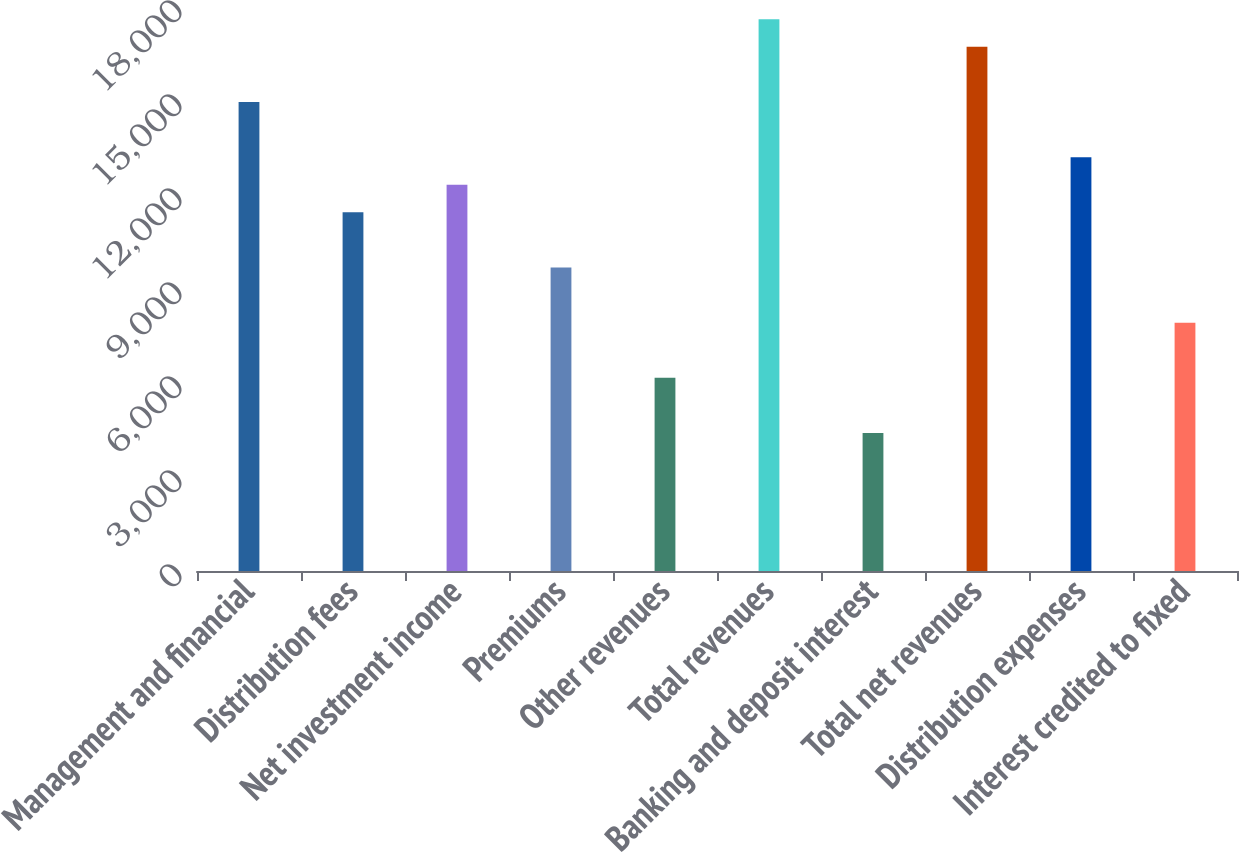Convert chart to OTSL. <chart><loc_0><loc_0><loc_500><loc_500><bar_chart><fcel>Management and financial<fcel>Distribution fees<fcel>Net investment income<fcel>Premiums<fcel>Other revenues<fcel>Total revenues<fcel>Banking and deposit interest<fcel>Total net revenues<fcel>Distribution expenses<fcel>Interest credited to fixed<nl><fcel>14968<fcel>11446.3<fcel>12326.7<fcel>9685.4<fcel>6163.64<fcel>17609.4<fcel>4402.76<fcel>16728.9<fcel>13207.2<fcel>7924.52<nl></chart> 